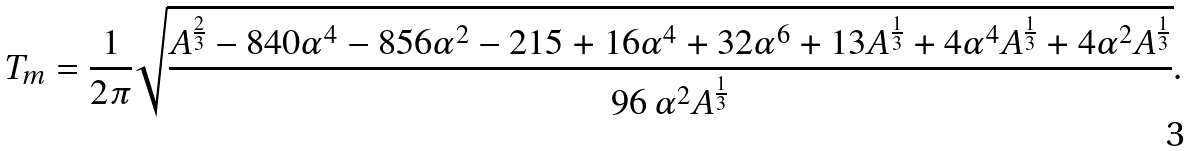<formula> <loc_0><loc_0><loc_500><loc_500>T _ { m } = \frac { 1 } { 2 \pi } \sqrt { \frac { A ^ { \frac { 2 } { 3 } } - 8 4 0 \alpha ^ { 4 } - 8 5 6 \alpha ^ { 2 } - 2 1 5 + 1 6 \alpha ^ { 4 } + 3 2 \alpha ^ { 6 } + 1 3 A ^ { \frac { 1 } { 3 } } + 4 \alpha ^ { 4 } A ^ { \frac { 1 } { 3 } } + 4 \alpha ^ { 2 } A ^ { \frac { 1 } { 3 } } } { 9 6 \, \alpha ^ { 2 } A ^ { \frac { 1 } { 3 } } } } .</formula> 